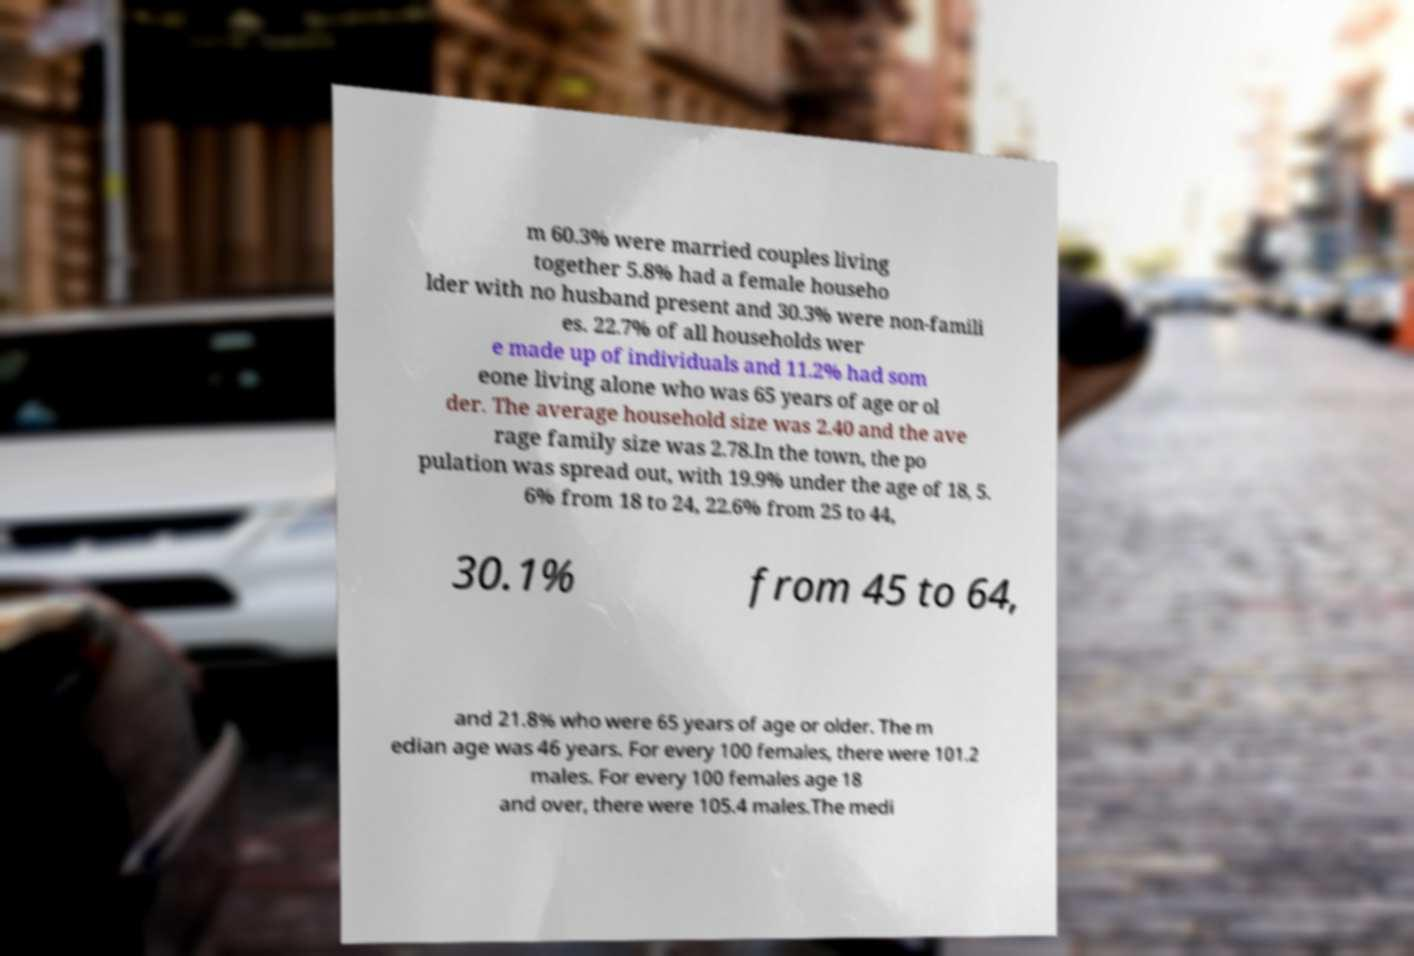There's text embedded in this image that I need extracted. Can you transcribe it verbatim? m 60.3% were married couples living together 5.8% had a female househo lder with no husband present and 30.3% were non-famili es. 22.7% of all households wer e made up of individuals and 11.2% had som eone living alone who was 65 years of age or ol der. The average household size was 2.40 and the ave rage family size was 2.78.In the town, the po pulation was spread out, with 19.9% under the age of 18, 5. 6% from 18 to 24, 22.6% from 25 to 44, 30.1% from 45 to 64, and 21.8% who were 65 years of age or older. The m edian age was 46 years. For every 100 females, there were 101.2 males. For every 100 females age 18 and over, there were 105.4 males.The medi 